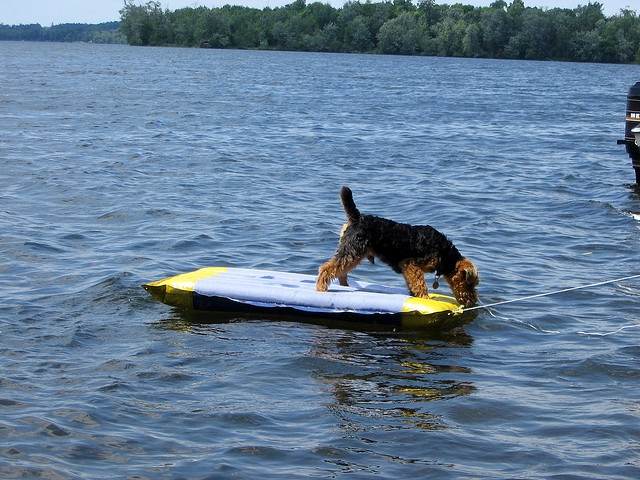Describe the objects in this image and their specific colors. I can see boat in lightblue, black, lavender, darkgray, and gray tones, dog in lightblue, black, maroon, and gray tones, and boat in lightblue, black, navy, gray, and white tones in this image. 